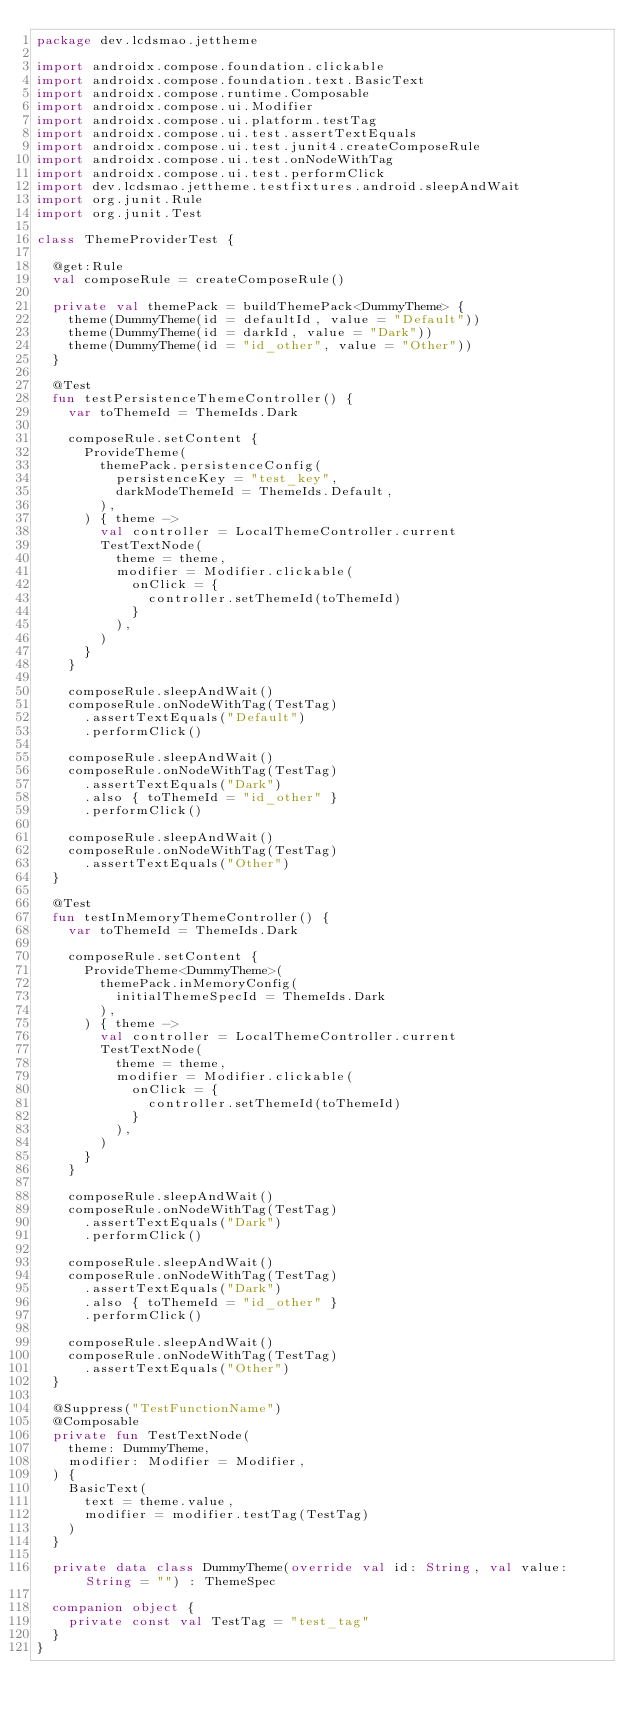<code> <loc_0><loc_0><loc_500><loc_500><_Kotlin_>package dev.lcdsmao.jettheme

import androidx.compose.foundation.clickable
import androidx.compose.foundation.text.BasicText
import androidx.compose.runtime.Composable
import androidx.compose.ui.Modifier
import androidx.compose.ui.platform.testTag
import androidx.compose.ui.test.assertTextEquals
import androidx.compose.ui.test.junit4.createComposeRule
import androidx.compose.ui.test.onNodeWithTag
import androidx.compose.ui.test.performClick
import dev.lcdsmao.jettheme.testfixtures.android.sleepAndWait
import org.junit.Rule
import org.junit.Test

class ThemeProviderTest {

  @get:Rule
  val composeRule = createComposeRule()

  private val themePack = buildThemePack<DummyTheme> {
    theme(DummyTheme(id = defaultId, value = "Default"))
    theme(DummyTheme(id = darkId, value = "Dark"))
    theme(DummyTheme(id = "id_other", value = "Other"))
  }

  @Test
  fun testPersistenceThemeController() {
    var toThemeId = ThemeIds.Dark

    composeRule.setContent {
      ProvideTheme(
        themePack.persistenceConfig(
          persistenceKey = "test_key",
          darkModeThemeId = ThemeIds.Default,
        ),
      ) { theme ->
        val controller = LocalThemeController.current
        TestTextNode(
          theme = theme,
          modifier = Modifier.clickable(
            onClick = {
              controller.setThemeId(toThemeId)
            }
          ),
        )
      }
    }

    composeRule.sleepAndWait()
    composeRule.onNodeWithTag(TestTag)
      .assertTextEquals("Default")
      .performClick()

    composeRule.sleepAndWait()
    composeRule.onNodeWithTag(TestTag)
      .assertTextEquals("Dark")
      .also { toThemeId = "id_other" }
      .performClick()

    composeRule.sleepAndWait()
    composeRule.onNodeWithTag(TestTag)
      .assertTextEquals("Other")
  }

  @Test
  fun testInMemoryThemeController() {
    var toThemeId = ThemeIds.Dark

    composeRule.setContent {
      ProvideTheme<DummyTheme>(
        themePack.inMemoryConfig(
          initialThemeSpecId = ThemeIds.Dark
        ),
      ) { theme ->
        val controller = LocalThemeController.current
        TestTextNode(
          theme = theme,
          modifier = Modifier.clickable(
            onClick = {
              controller.setThemeId(toThemeId)
            }
          ),
        )
      }
    }

    composeRule.sleepAndWait()
    composeRule.onNodeWithTag(TestTag)
      .assertTextEquals("Dark")
      .performClick()

    composeRule.sleepAndWait()
    composeRule.onNodeWithTag(TestTag)
      .assertTextEquals("Dark")
      .also { toThemeId = "id_other" }
      .performClick()

    composeRule.sleepAndWait()
    composeRule.onNodeWithTag(TestTag)
      .assertTextEquals("Other")
  }

  @Suppress("TestFunctionName")
  @Composable
  private fun TestTextNode(
    theme: DummyTheme,
    modifier: Modifier = Modifier,
  ) {
    BasicText(
      text = theme.value,
      modifier = modifier.testTag(TestTag)
    )
  }

  private data class DummyTheme(override val id: String, val value: String = "") : ThemeSpec

  companion object {
    private const val TestTag = "test_tag"
  }
}
</code> 